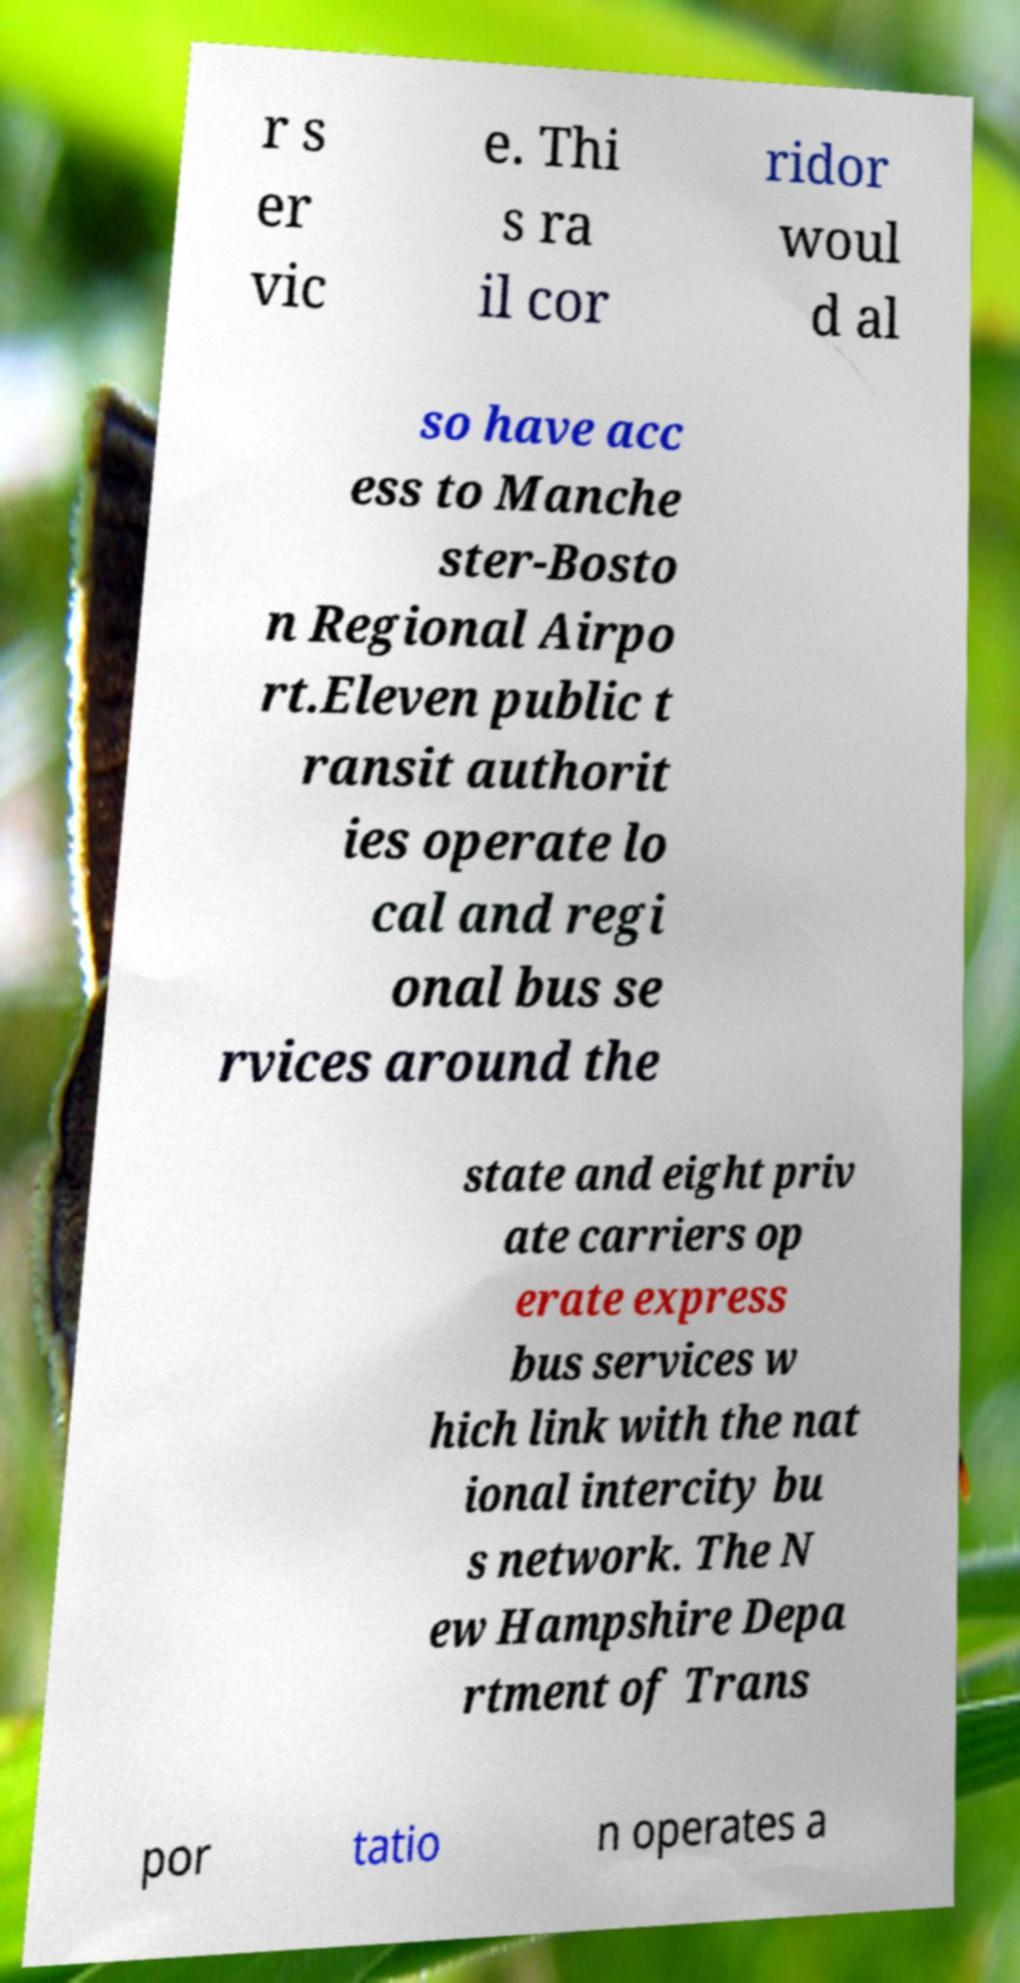Can you read and provide the text displayed in the image?This photo seems to have some interesting text. Can you extract and type it out for me? r s er vic e. Thi s ra il cor ridor woul d al so have acc ess to Manche ster-Bosto n Regional Airpo rt.Eleven public t ransit authorit ies operate lo cal and regi onal bus se rvices around the state and eight priv ate carriers op erate express bus services w hich link with the nat ional intercity bu s network. The N ew Hampshire Depa rtment of Trans por tatio n operates a 